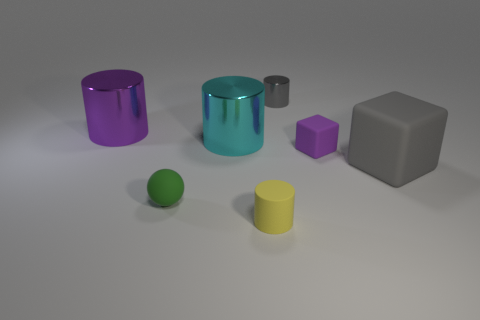There is a small cylinder that is the same material as the big purple object; what is its color?
Offer a terse response. Gray. What number of purple rubber cubes are the same size as the cyan cylinder?
Offer a very short reply. 0. What number of brown objects are either tiny rubber cylinders or big shiny things?
Ensure brevity in your answer.  0. How many things are either cyan shiny cylinders or objects to the left of the tiny green ball?
Your response must be concise. 2. There is a object to the right of the small purple rubber cube; what is its material?
Keep it short and to the point. Rubber. The other metal object that is the same size as the yellow object is what shape?
Your response must be concise. Cylinder. Are there any other tiny objects of the same shape as the cyan metal object?
Provide a short and direct response. Yes. Are the small gray object and the large cylinder that is left of the cyan cylinder made of the same material?
Provide a succinct answer. Yes. The small thing that is right of the shiny cylinder right of the tiny rubber cylinder is made of what material?
Keep it short and to the point. Rubber. Are there more big purple things in front of the large gray thing than tiny gray metal cylinders?
Offer a terse response. No. 